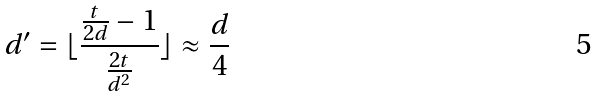<formula> <loc_0><loc_0><loc_500><loc_500>d ^ { \prime } = \lfloor \frac { \frac { t } { 2 d } - 1 } { \frac { 2 t } { d ^ { 2 } } } \rfloor \approx \frac { d } { 4 }</formula> 